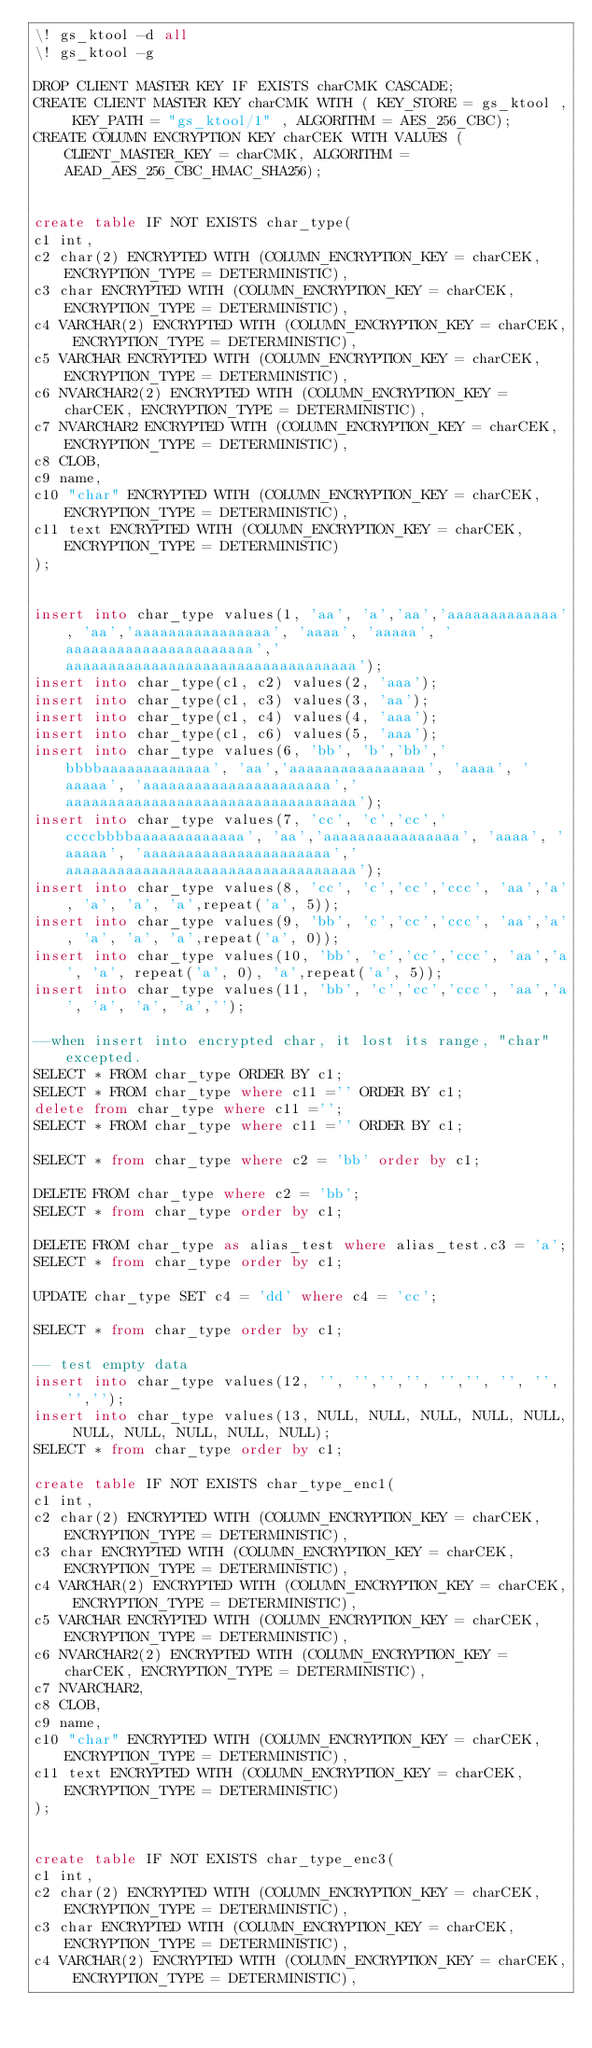<code> <loc_0><loc_0><loc_500><loc_500><_SQL_>\! gs_ktool -d all
\! gs_ktool -g

DROP CLIENT MASTER KEY IF EXISTS charCMK CASCADE;
CREATE CLIENT MASTER KEY charCMK WITH ( KEY_STORE = gs_ktool , KEY_PATH = "gs_ktool/1" , ALGORITHM = AES_256_CBC);
CREATE COLUMN ENCRYPTION KEY charCEK WITH VALUES (CLIENT_MASTER_KEY = charCMK, ALGORITHM = AEAD_AES_256_CBC_HMAC_SHA256);


create table IF NOT EXISTS char_type(
c1 int,
c2 char(2) ENCRYPTED WITH (COLUMN_ENCRYPTION_KEY = charCEK, ENCRYPTION_TYPE = DETERMINISTIC),
c3 char ENCRYPTED WITH (COLUMN_ENCRYPTION_KEY = charCEK, ENCRYPTION_TYPE = DETERMINISTIC),
c4 VARCHAR(2) ENCRYPTED WITH (COLUMN_ENCRYPTION_KEY = charCEK, ENCRYPTION_TYPE = DETERMINISTIC),
c5 VARCHAR ENCRYPTED WITH (COLUMN_ENCRYPTION_KEY = charCEK, ENCRYPTION_TYPE = DETERMINISTIC),
c6 NVARCHAR2(2) ENCRYPTED WITH (COLUMN_ENCRYPTION_KEY = charCEK, ENCRYPTION_TYPE = DETERMINISTIC),
c7 NVARCHAR2 ENCRYPTED WITH (COLUMN_ENCRYPTION_KEY = charCEK, ENCRYPTION_TYPE = DETERMINISTIC),
c8 CLOB,
c9 name,
c10 "char" ENCRYPTED WITH (COLUMN_ENCRYPTION_KEY = charCEK, ENCRYPTION_TYPE = DETERMINISTIC),
c11 text ENCRYPTED WITH (COLUMN_ENCRYPTION_KEY = charCEK, ENCRYPTION_TYPE = DETERMINISTIC)
);


insert into char_type values(1, 'aa', 'a','aa','aaaaaaaaaaaaa', 'aa','aaaaaaaaaaaaaaaa', 'aaaa', 'aaaaa', 'aaaaaaaaaaaaaaaaaaaaaa','aaaaaaaaaaaaaaaaaaaaaaaaaaaaaaaaaa');
insert into char_type(c1, c2) values(2, 'aaa');
insert into char_type(c1, c3) values(3, 'aa');
insert into char_type(c1, c4) values(4, 'aaa');
insert into char_type(c1, c6) values(5, 'aaa');
insert into char_type values(6, 'bb', 'b','bb','bbbbaaaaaaaaaaaaa', 'aa','aaaaaaaaaaaaaaaa', 'aaaa', 'aaaaa', 'aaaaaaaaaaaaaaaaaaaaaa','aaaaaaaaaaaaaaaaaaaaaaaaaaaaaaaaaa');
insert into char_type values(7, 'cc', 'c','cc','ccccbbbbaaaaaaaaaaaaa', 'aa','aaaaaaaaaaaaaaaa', 'aaaa', 'aaaaa', 'aaaaaaaaaaaaaaaaaaaaaa','aaaaaaaaaaaaaaaaaaaaaaaaaaaaaaaaaa');
insert into char_type values(8, 'cc', 'c','cc','ccc', 'aa','a', 'a', 'a', 'a',repeat('a', 5));
insert into char_type values(9, 'bb', 'c','cc','ccc', 'aa','a', 'a', 'a', 'a',repeat('a', 0));
insert into char_type values(10, 'bb', 'c','cc','ccc', 'aa','a', 'a', repeat('a', 0), 'a',repeat('a', 5));
insert into char_type values(11, 'bb', 'c','cc','ccc', 'aa','a', 'a', 'a', 'a','');

--when insert into encrypted char, it lost its range, "char" excepted.
SELECT * FROM char_type ORDER BY c1;
SELECT * FROM char_type where c11 ='' ORDER BY c1;
delete from char_type where c11 ='';
SELECT * FROM char_type where c11 ='' ORDER BY c1;

SELECT * from char_type where c2 = 'bb' order by c1;

DELETE FROM char_type where c2 = 'bb';
SELECT * from char_type order by c1;

DELETE FROM char_type as alias_test where alias_test.c3 = 'a';
SELECT * from char_type order by c1;

UPDATE char_type SET c4 = 'dd' where c4 = 'cc';

SELECT * from char_type order by c1;

-- test empty data
insert into char_type values(12, '', '','','', '','', '', '', '','');
insert into char_type values(13, NULL, NULL, NULL, NULL, NULL, NULL, NULL, NULL, NULL, NULL);
SELECT * from char_type order by c1;

create table IF NOT EXISTS char_type_enc1(
c1 int,
c2 char(2) ENCRYPTED WITH (COLUMN_ENCRYPTION_KEY = charCEK, ENCRYPTION_TYPE = DETERMINISTIC),
c3 char ENCRYPTED WITH (COLUMN_ENCRYPTION_KEY = charCEK, ENCRYPTION_TYPE = DETERMINISTIC),
c4 VARCHAR(2) ENCRYPTED WITH (COLUMN_ENCRYPTION_KEY = charCEK, ENCRYPTION_TYPE = DETERMINISTIC),
c5 VARCHAR ENCRYPTED WITH (COLUMN_ENCRYPTION_KEY = charCEK, ENCRYPTION_TYPE = DETERMINISTIC),
c6 NVARCHAR2(2) ENCRYPTED WITH (COLUMN_ENCRYPTION_KEY = charCEK, ENCRYPTION_TYPE = DETERMINISTIC),
c7 NVARCHAR2,
c8 CLOB,
c9 name,
c10 "char" ENCRYPTED WITH (COLUMN_ENCRYPTION_KEY = charCEK, ENCRYPTION_TYPE = DETERMINISTIC),
c11 text ENCRYPTED WITH (COLUMN_ENCRYPTION_KEY = charCEK, ENCRYPTION_TYPE = DETERMINISTIC)
);


create table IF NOT EXISTS char_type_enc3(
c1 int,
c2 char(2) ENCRYPTED WITH (COLUMN_ENCRYPTION_KEY = charCEK, ENCRYPTION_TYPE = DETERMINISTIC),
c3 char ENCRYPTED WITH (COLUMN_ENCRYPTION_KEY = charCEK, ENCRYPTION_TYPE = DETERMINISTIC),
c4 VARCHAR(2) ENCRYPTED WITH (COLUMN_ENCRYPTION_KEY = charCEK, ENCRYPTION_TYPE = DETERMINISTIC),</code> 